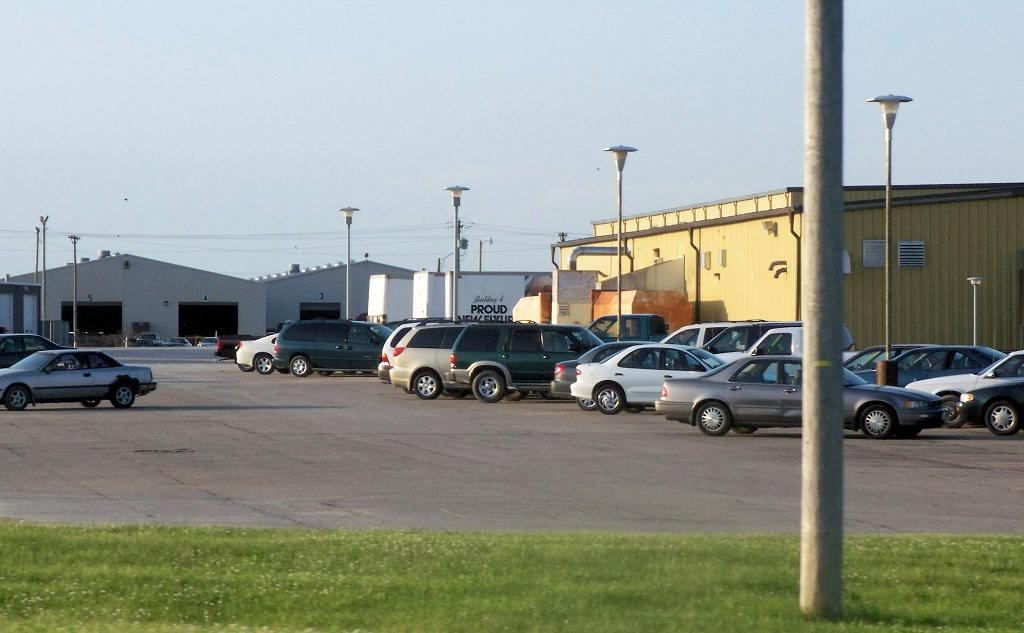Can you describe this image briefly? In this image I can see few vehicles, light poles, background I can see few sheds and the sky is in white color. 